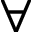Convert formula to latex. <formula><loc_0><loc_0><loc_500><loc_500>\forall</formula> 